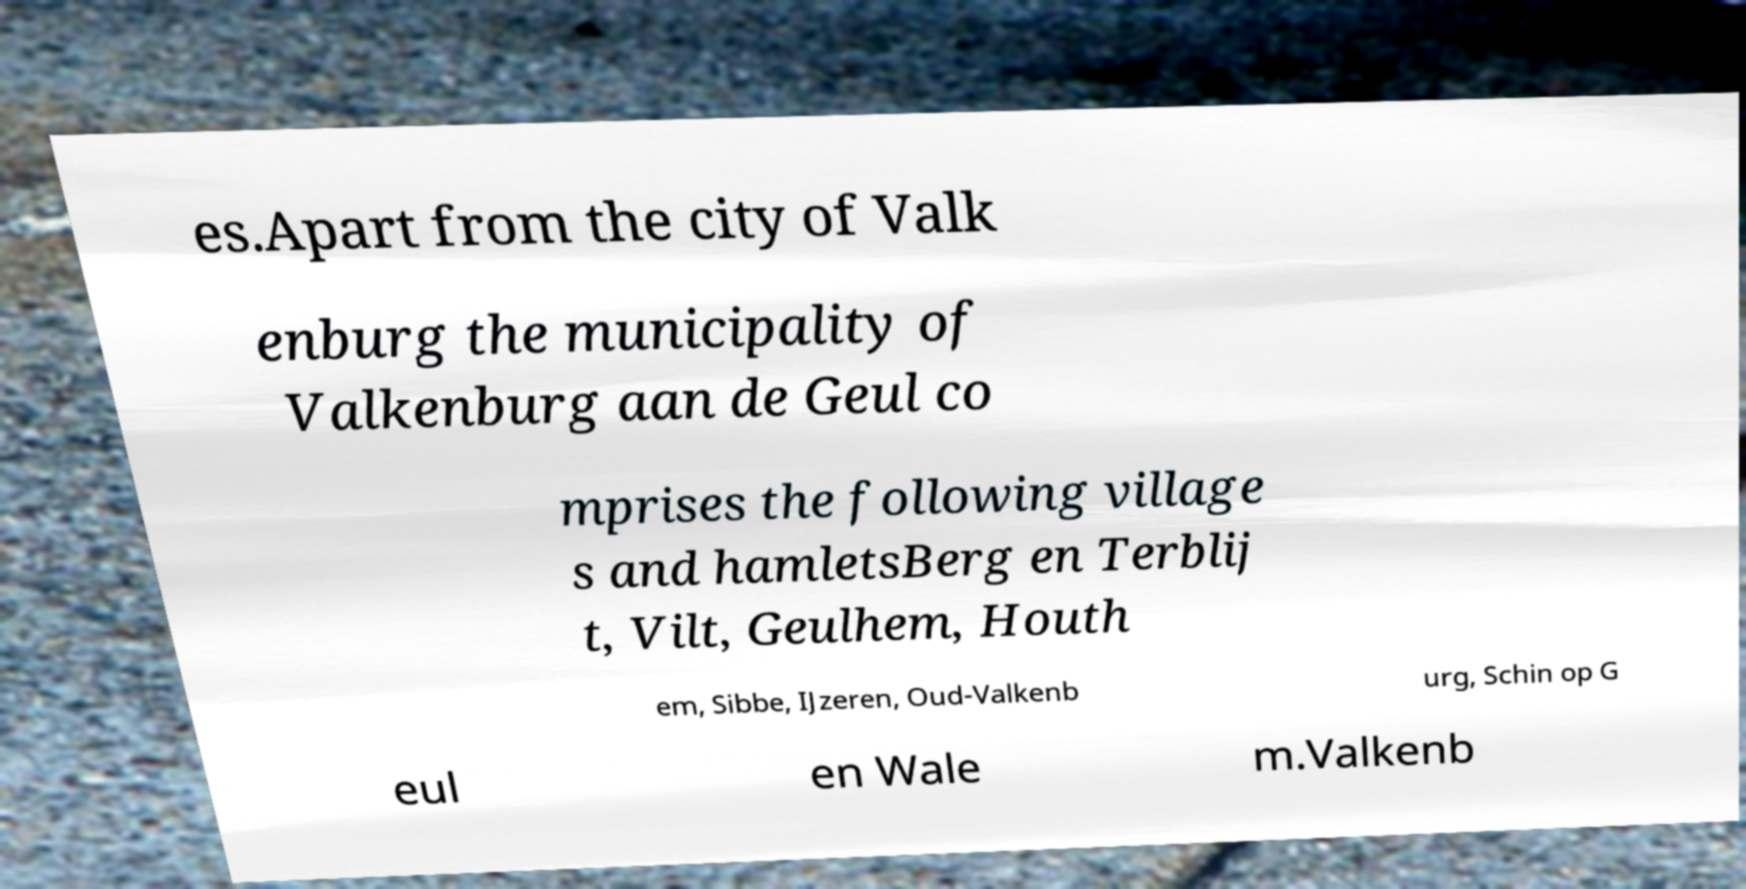Please read and relay the text visible in this image. What does it say? es.Apart from the city of Valk enburg the municipality of Valkenburg aan de Geul co mprises the following village s and hamletsBerg en Terblij t, Vilt, Geulhem, Houth em, Sibbe, IJzeren, Oud-Valkenb urg, Schin op G eul en Wale m.Valkenb 